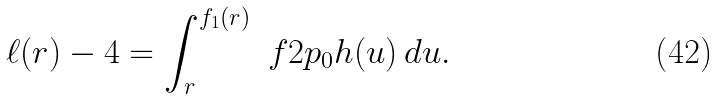Convert formula to latex. <formula><loc_0><loc_0><loc_500><loc_500>\ell ( r ) - 4 = \int _ { r } ^ { f _ { 1 } ( r ) } \ f { 2 } { p _ { 0 } h ( u ) } \, d u .</formula> 